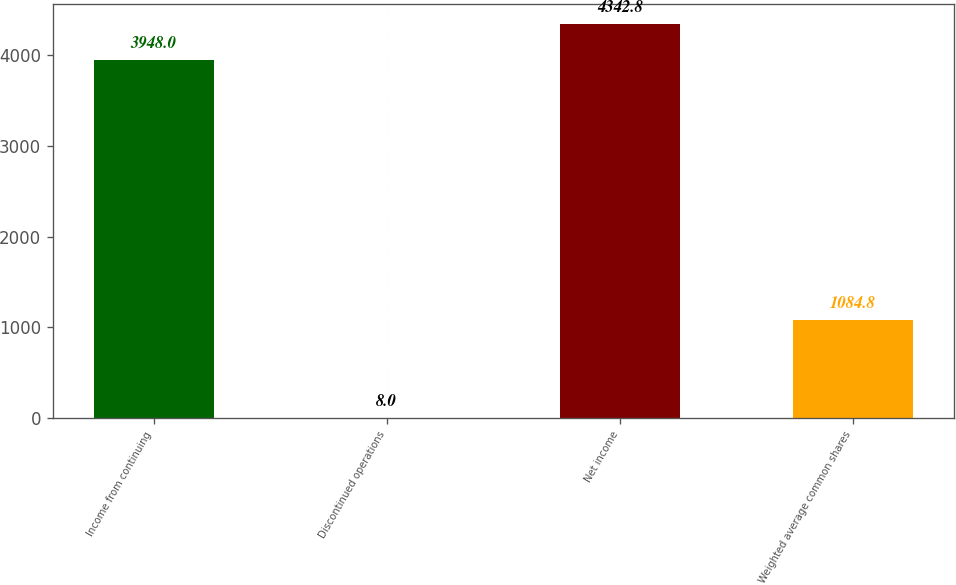<chart> <loc_0><loc_0><loc_500><loc_500><bar_chart><fcel>Income from continuing<fcel>Discontinued operations<fcel>Net income<fcel>Weighted average common shares<nl><fcel>3948<fcel>8<fcel>4342.8<fcel>1084.8<nl></chart> 